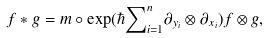<formula> <loc_0><loc_0><loc_500><loc_500>f * g = m \circ \exp ( \hbar { \sum } _ { i = 1 } ^ { n } \partial _ { y _ { i } } \otimes \partial _ { x _ { i } } ) f \otimes g ,</formula> 